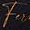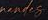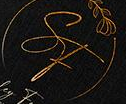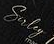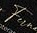What text appears in these images from left to right, separated by a semicolon? Fu; #####; SF; Suley; Fu 